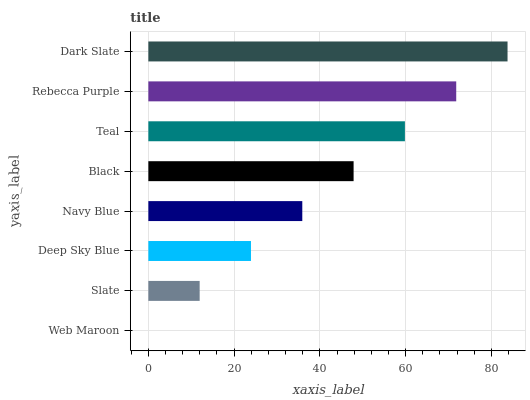Is Web Maroon the minimum?
Answer yes or no. Yes. Is Dark Slate the maximum?
Answer yes or no. Yes. Is Slate the minimum?
Answer yes or no. No. Is Slate the maximum?
Answer yes or no. No. Is Slate greater than Web Maroon?
Answer yes or no. Yes. Is Web Maroon less than Slate?
Answer yes or no. Yes. Is Web Maroon greater than Slate?
Answer yes or no. No. Is Slate less than Web Maroon?
Answer yes or no. No. Is Black the high median?
Answer yes or no. Yes. Is Navy Blue the low median?
Answer yes or no. Yes. Is Web Maroon the high median?
Answer yes or no. No. Is Web Maroon the low median?
Answer yes or no. No. 